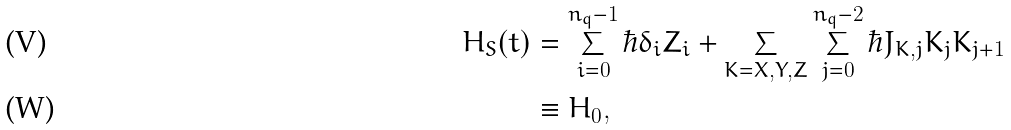<formula> <loc_0><loc_0><loc_500><loc_500>H _ { S } ( t ) & = \sum _ { i = 0 } ^ { n _ { q } - 1 } \hbar { \delta } _ { i } Z _ { i } + \sum _ { K = X , Y , Z } \sum _ { j = 0 } ^ { n _ { q } - 2 } \hbar { J } _ { K , j } K _ { j } K _ { j + 1 } \\ & \equiv H _ { 0 } ,</formula> 